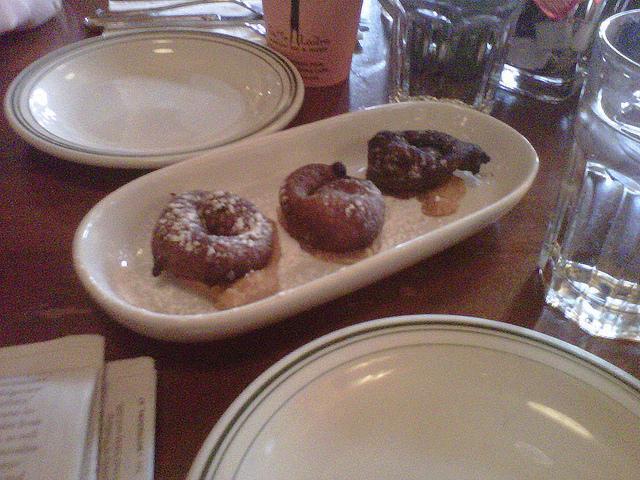How many donuts are in this picture?
Give a very brief answer. 3. How many cups are in the picture?
Give a very brief answer. 3. How many donuts are there?
Give a very brief answer. 3. How many scissors are there?
Give a very brief answer. 0. 